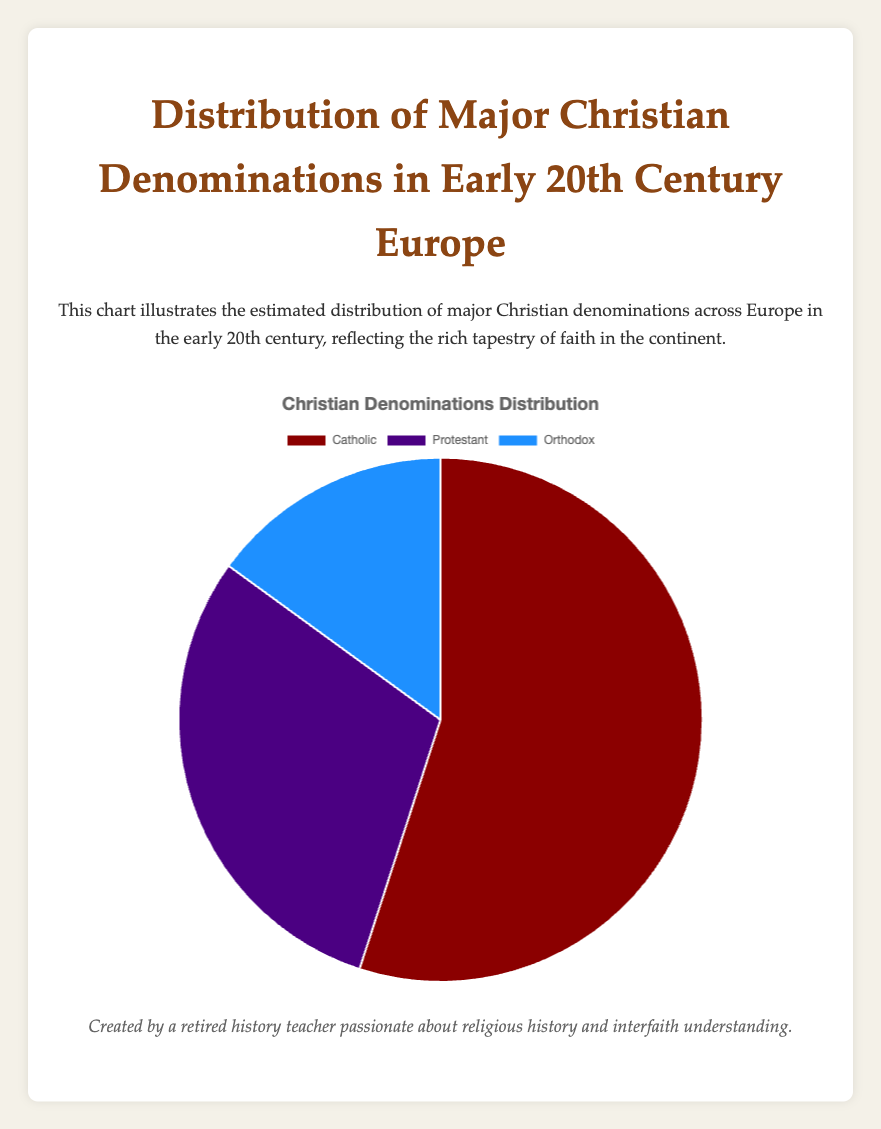What percentage of the European population in the early 20th century was Protestant? The percentage for Protestants is directly shown in the figure as part of the distribution of major Christian denominations. According to the data, 30% of the European population adhered to Protestantism.
Answer: 30% Between Catholics and Orthodox Christians, which denomination had a larger population share? The figure indicates that Catholics made up 55% of the population, while Orthodox Christians made up 15%. Since 55% is greater than 15%, Catholics had a larger population share.
Answer: Catholics What is the total percentage of Christians in Europe that were either Catholic or Orthodox? To find the total percentage for Catholics and Orthodox combined, add the individual percentages: 55% for Catholics and 15% for Orthodox. 55% + 15% = 70%.
Answer: 70% Which major Christian denomination had the smallest population share in early 20th century Europe? The figure shows three denominations: Catholic (55%), Protestant (30%), and Orthodox (15%). Among these, Orthodox Christians had the smallest population share, at 15%.
Answer: Orthodox How much larger was the population percentage of Catholics compared to Protestants? To determine the difference between the percentages for Catholics and Protestants, subtract the percentage of Protestants from that of Catholics: 55% - 30% = 25%.
Answer: 25% What is the combined population percentage of Protestants and Orthodox Christians? Add the percentages of Protestants (30%) and Orthodox Christians (15%) to get the combined percentage: 30% + 15% = 45%.
Answer: 45% If you were to visually describe the color associated with the largest denomination, what color would it be? The figure uses distinct colors to represent each denomination. According to the figure, the color for the largest denomination, Catholic, is red.
Answer: Red Which denomination has a distribution percentage closest to one-third of the total percentage? One-third of 100% is approximately 33.33%. The figure shows that Protestants have a distribution of 30%, which is closest to one-third of the total percentage compared to the other denominations.
Answer: Protestant 